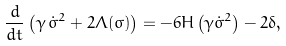<formula> <loc_0><loc_0><loc_500><loc_500>\frac { d } { d t } \left ( { \gamma } \, \dot { \sigma } ^ { 2 } + 2 \Lambda ( \sigma ) \right ) = - 6 H \left ( \gamma \dot { \sigma } ^ { 2 } \right ) - 2 \delta ,</formula> 